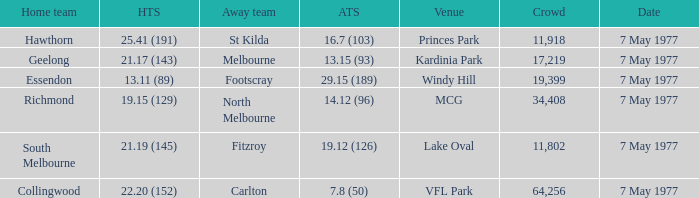Name the venue with a home team of geelong Kardinia Park. 